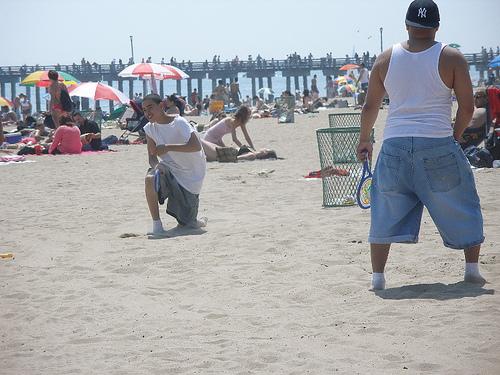Do you see a baseball cap?
Give a very brief answer. Yes. Why are these men shirtless?
Quick response, please. Beach. Is the garbage full?
Short answer required. No. How many umbrellas do you see?
Concise answer only. 6. Are these people at a beach?
Quick response, please. Yes. 